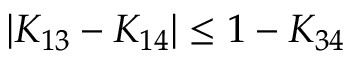<formula> <loc_0><loc_0><loc_500><loc_500>| K _ { 1 3 } - K _ { 1 4 } | \leq 1 - K _ { 3 4 }</formula> 